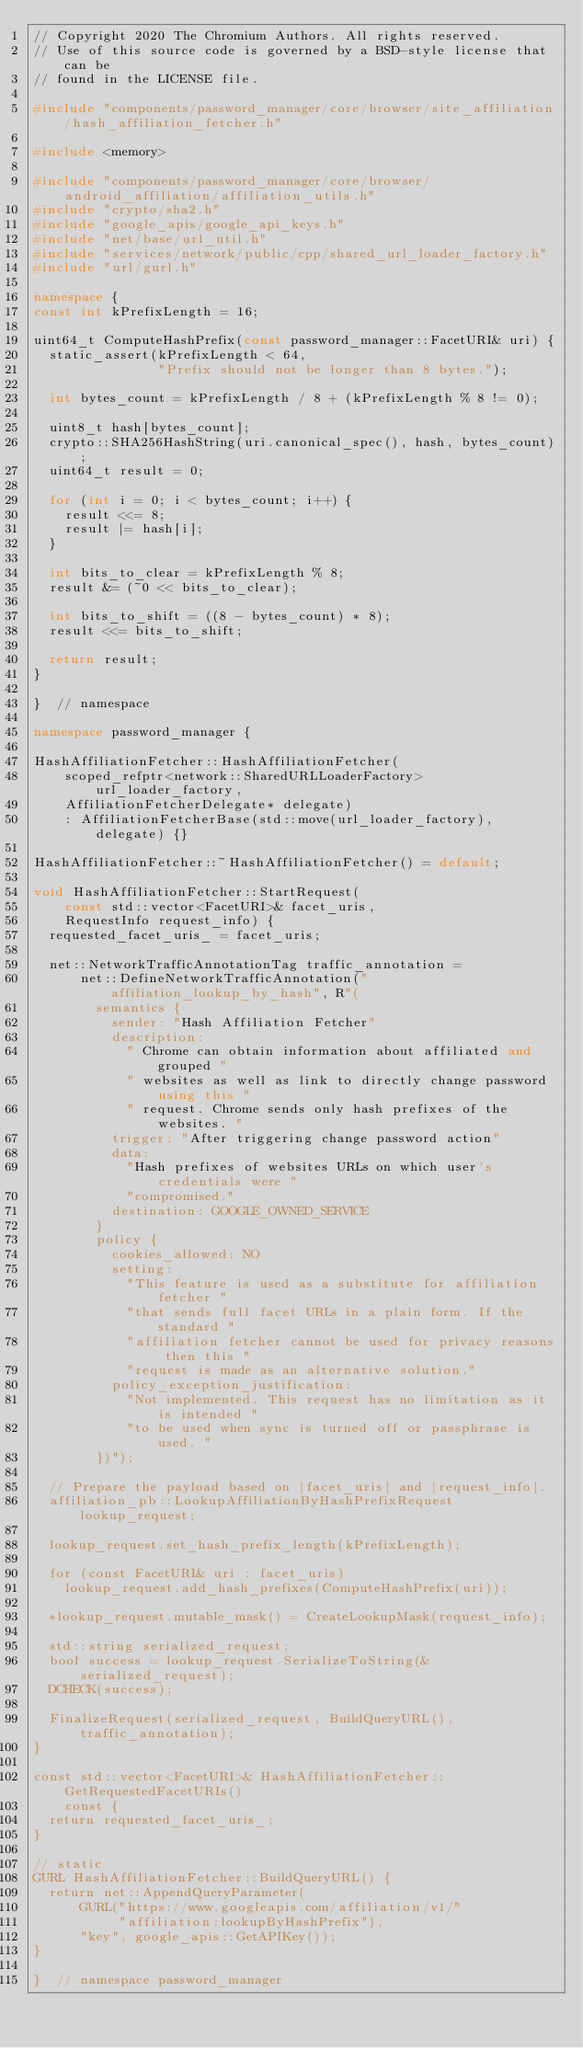Convert code to text. <code><loc_0><loc_0><loc_500><loc_500><_C++_>// Copyright 2020 The Chromium Authors. All rights reserved.
// Use of this source code is governed by a BSD-style license that can be
// found in the LICENSE file.

#include "components/password_manager/core/browser/site_affiliation/hash_affiliation_fetcher.h"

#include <memory>

#include "components/password_manager/core/browser/android_affiliation/affiliation_utils.h"
#include "crypto/sha2.h"
#include "google_apis/google_api_keys.h"
#include "net/base/url_util.h"
#include "services/network/public/cpp/shared_url_loader_factory.h"
#include "url/gurl.h"

namespace {
const int kPrefixLength = 16;

uint64_t ComputeHashPrefix(const password_manager::FacetURI& uri) {
  static_assert(kPrefixLength < 64,
                "Prefix should not be longer than 8 bytes.");

  int bytes_count = kPrefixLength / 8 + (kPrefixLength % 8 != 0);

  uint8_t hash[bytes_count];
  crypto::SHA256HashString(uri.canonical_spec(), hash, bytes_count);
  uint64_t result = 0;

  for (int i = 0; i < bytes_count; i++) {
    result <<= 8;
    result |= hash[i];
  }

  int bits_to_clear = kPrefixLength % 8;
  result &= (~0 << bits_to_clear);

  int bits_to_shift = ((8 - bytes_count) * 8);
  result <<= bits_to_shift;

  return result;
}

}  // namespace

namespace password_manager {

HashAffiliationFetcher::HashAffiliationFetcher(
    scoped_refptr<network::SharedURLLoaderFactory> url_loader_factory,
    AffiliationFetcherDelegate* delegate)
    : AffiliationFetcherBase(std::move(url_loader_factory), delegate) {}

HashAffiliationFetcher::~HashAffiliationFetcher() = default;

void HashAffiliationFetcher::StartRequest(
    const std::vector<FacetURI>& facet_uris,
    RequestInfo request_info) {
  requested_facet_uris_ = facet_uris;

  net::NetworkTrafficAnnotationTag traffic_annotation =
      net::DefineNetworkTrafficAnnotation("affiliation_lookup_by_hash", R"(
        semantics {
          sender: "Hash Affiliation Fetcher"
          description:
            " Chrome can obtain information about affiliated and grouped "
            " websites as well as link to directly change password using this "
            " request. Chrome sends only hash prefixes of the websites. "
          trigger: "After triggering change password action"
          data:
            "Hash prefixes of websites URLs on which user's credentials were "
            "compromised."
          destination: GOOGLE_OWNED_SERVICE
        }
        policy {
          cookies_allowed: NO
          setting:
            "This feature is used as a substitute for affiliation fetcher "
            "that sends full facet URLs in a plain form. If the standard "
            "affiliation fetcher cannot be used for privacy reasons then this "
            "request is made as an alternative solution."
          policy_exception_justification:
            "Not implemented. This request has no limitation as it is intended "
            "to be used when sync is turned off or passphrase is used. "
        })");

  // Prepare the payload based on |facet_uris| and |request_info|.
  affiliation_pb::LookupAffiliationByHashPrefixRequest lookup_request;

  lookup_request.set_hash_prefix_length(kPrefixLength);

  for (const FacetURI& uri : facet_uris)
    lookup_request.add_hash_prefixes(ComputeHashPrefix(uri));

  *lookup_request.mutable_mask() = CreateLookupMask(request_info);

  std::string serialized_request;
  bool success = lookup_request.SerializeToString(&serialized_request);
  DCHECK(success);

  FinalizeRequest(serialized_request, BuildQueryURL(), traffic_annotation);
}

const std::vector<FacetURI>& HashAffiliationFetcher::GetRequestedFacetURIs()
    const {
  return requested_facet_uris_;
}

// static
GURL HashAffiliationFetcher::BuildQueryURL() {
  return net::AppendQueryParameter(
      GURL("https://www.googleapis.com/affiliation/v1/"
           "affiliation:lookupByHashPrefix"),
      "key", google_apis::GetAPIKey());
}

}  // namespace password_manager
</code> 